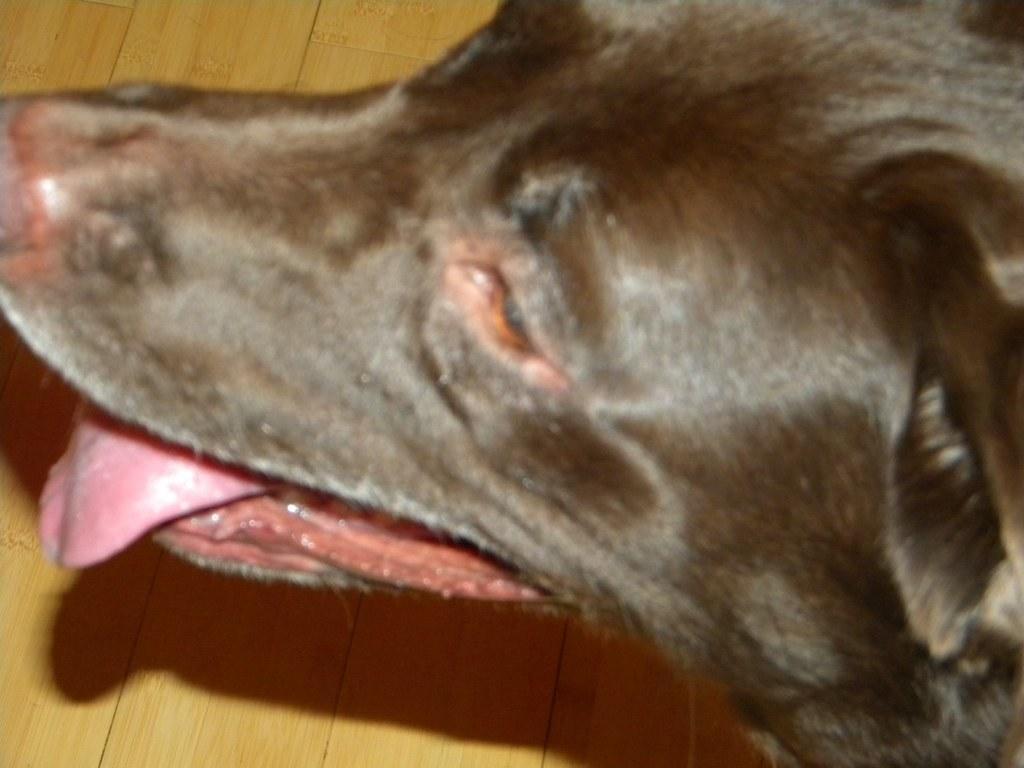How would you summarize this image in a sentence or two? In this image we can see a dog and in the background, we can see the wall. 